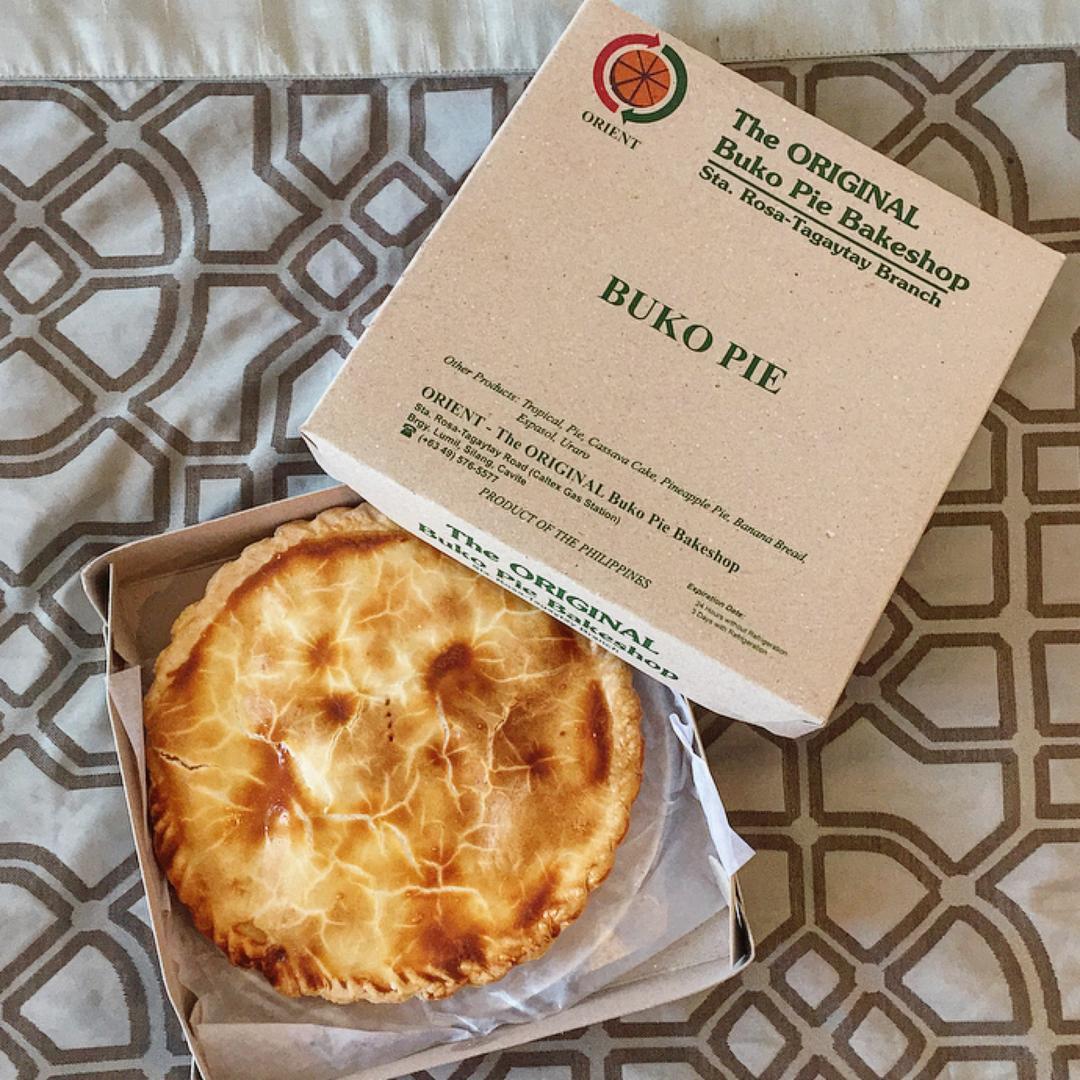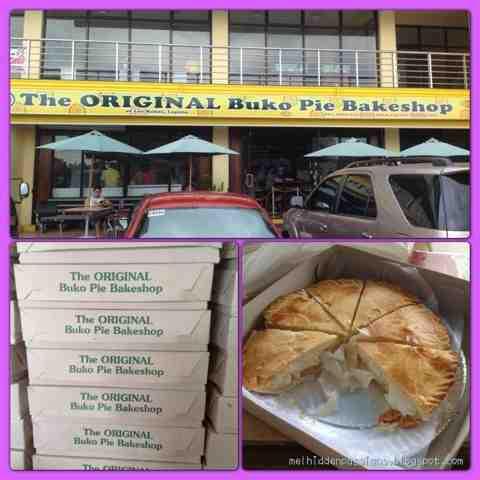The first image is the image on the left, the second image is the image on the right. Analyze the images presented: Is the assertion "In at least one image there is a bunko pie missing at least one slice." valid? Answer yes or no. Yes. The first image is the image on the left, the second image is the image on the right. Assess this claim about the two images: "A pie is in an open box.". Correct or not? Answer yes or no. Yes. 